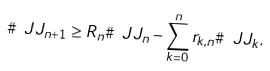Convert formula to latex. <formula><loc_0><loc_0><loc_500><loc_500>\# \ J J _ { n + 1 } \geq R _ { n } \# \ J J _ { n } - \sum _ { k = 0 } ^ { n } r _ { k , n } \# \ J J _ { k } .</formula> 